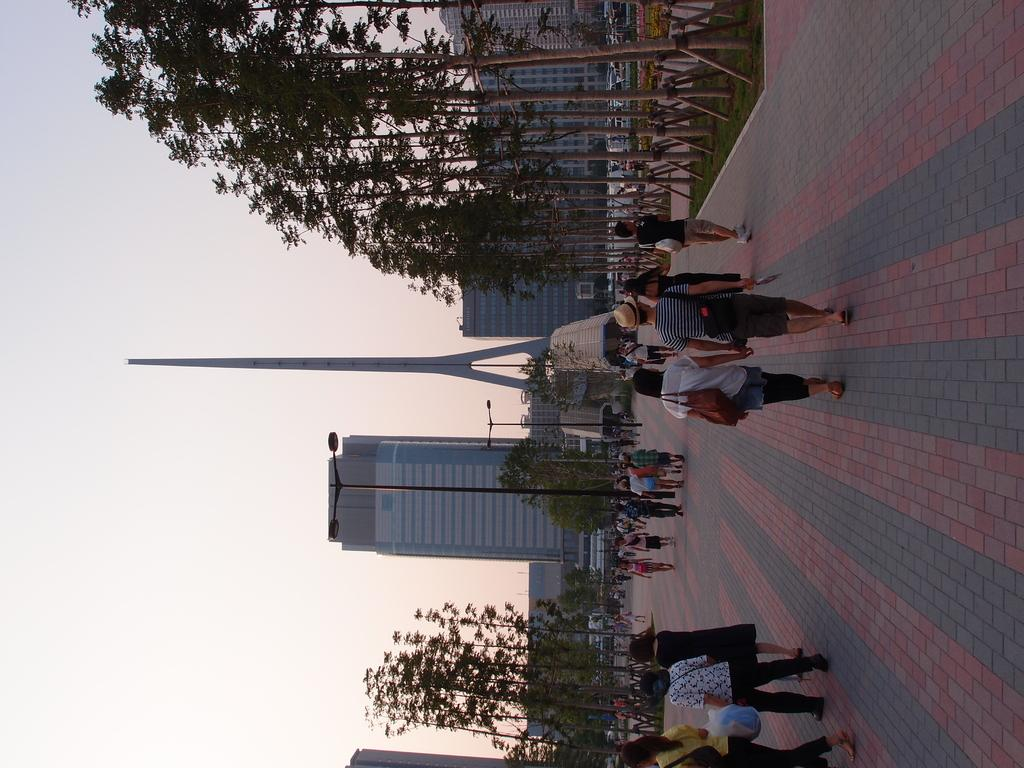What type of structures are present in the image? There are buildings in the image. What other natural elements can be seen in the image? There are trees in the image. What are the light poles used for in the image? The light poles are used for illumination in the image. What type of transportation is visible in the image? There are vehicles in the image. What are the people in the image doing? The people in the image are walking. What colors are used to depict the sky in the image? The sky is in white and blue color in the image. Can you tell me how many cables are attached to the light poles in the image? There is no mention of cables attached to the light poles in the image; only the light poles themselves are visible. What type of tin is being used to construct the buildings in the image? There is no mention of tin being used to construct the buildings in the image; the buildings are made of other materials. 